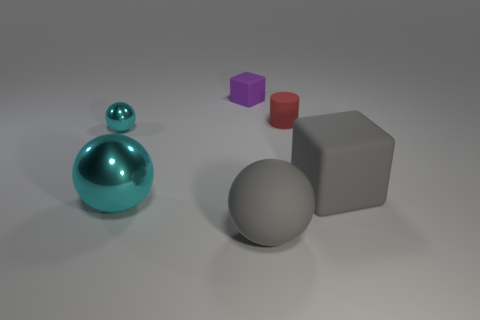Subtract all large gray balls. How many balls are left? 2 Subtract 2 balls. How many balls are left? 1 Add 2 tiny cylinders. How many objects exist? 8 Subtract all gray balls. How many balls are left? 2 Subtract all cylinders. How many objects are left? 5 Add 6 large gray blocks. How many large gray blocks are left? 7 Add 1 purple rubber blocks. How many purple rubber blocks exist? 2 Subtract 0 purple balls. How many objects are left? 6 Subtract all brown cubes. Subtract all blue cylinders. How many cubes are left? 2 Subtract all gray cylinders. How many purple cubes are left? 1 